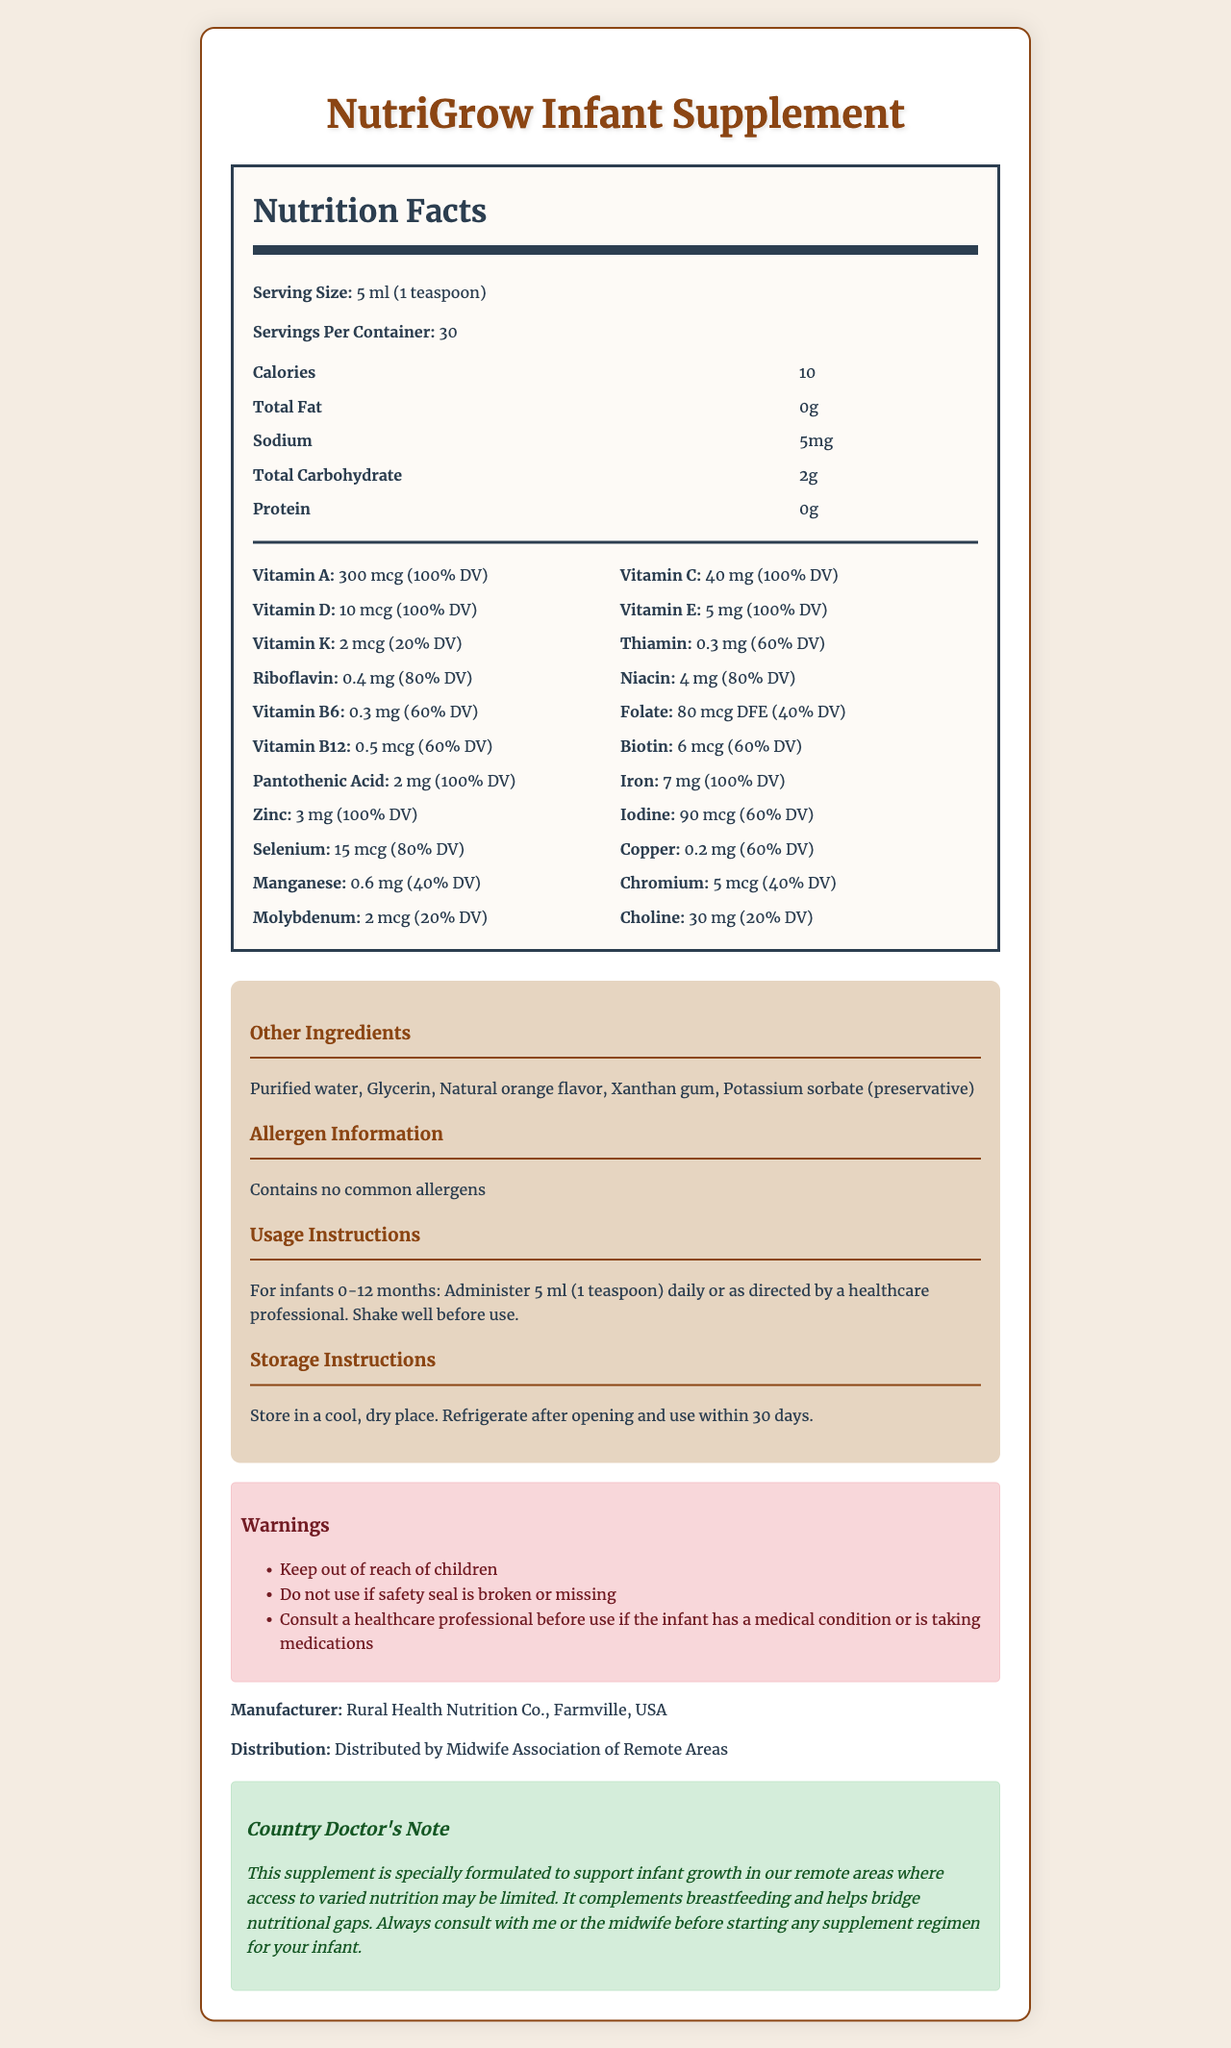what is the serving size? The serving size is clearly listed at the top of the Nutrition Facts section.
Answer: 5 ml (1 teaspoon) how many servings are in a container? The document states that there are 30 servings per container.
Answer: 30 how many calories are in one serving? The calorie count per serving is listed as 10 calories.
Answer: 10 what percentage of the daily value (DV) does Vitamin A contribute? The label indicates that Vitamin A constitutes 100% of the daily value.
Answer: 100% DV does the supplement contain any protein? The protein content is listed as 0g in the document.
Answer: No which vitamin has the highest daily value percentage? A. Vitamin C B. Vitamin A C. Vitamin D D. Vitamin K Vitamin C is listed as providing 100% of the daily value, which is the highest among the options given.
Answer: A. Vitamin C how much iron does one serving of this supplement provide? The label specifies that one serving contains 7 mg of iron.
Answer: 7 mg is Vitamin B6 present in the supplement? Vitamin B6 is listed in the nutrition section with 0.3 mg, contributing 60% of the daily value.
Answer: Yes which ingredient is used as a preservative? A. Xanthan gum B. Potassium sorbate C. Natural orange flavor D. Glycerin Potassium sorbate is mentioned as a preservative in the document.
Answer: B. Potassium sorbate should you consult a healthcare professional before using this supplement if the infant has a medical condition? One of the warnings states to consult a healthcare professional if the infant has a medical condition or is taking medications.
Answer: Yes describe the main idea of the document The main idea revolves around explaining the purpose and details of the NutriGrow Infant Supplement, including its nutritional values, ingredients, recommended usage, storage instructions, and warnings.
Answer: The document provides detailed information on the nutritional content, ingredients, usage instructions, and warnings for NutriGrow Infant Supplement. It is designed to support infant growth in resource-limited settings. does the supplement contain allergens? The document states "Contains no common allergens."
Answer: No what is the specific function of the midwife in distributing the supplement? The document does not provide specific details about the midwife's role beyond distribution.
Answer: Not enough information where should the supplement be stored after opening? The storage instructions indicate that the supplement should be refrigerated after opening.
Answer: Refrigerate can this supplement replace breastfeeding? The country doctor's note mentions that the supplement is to complement breastfeeding, not replace it.
Answer: No 